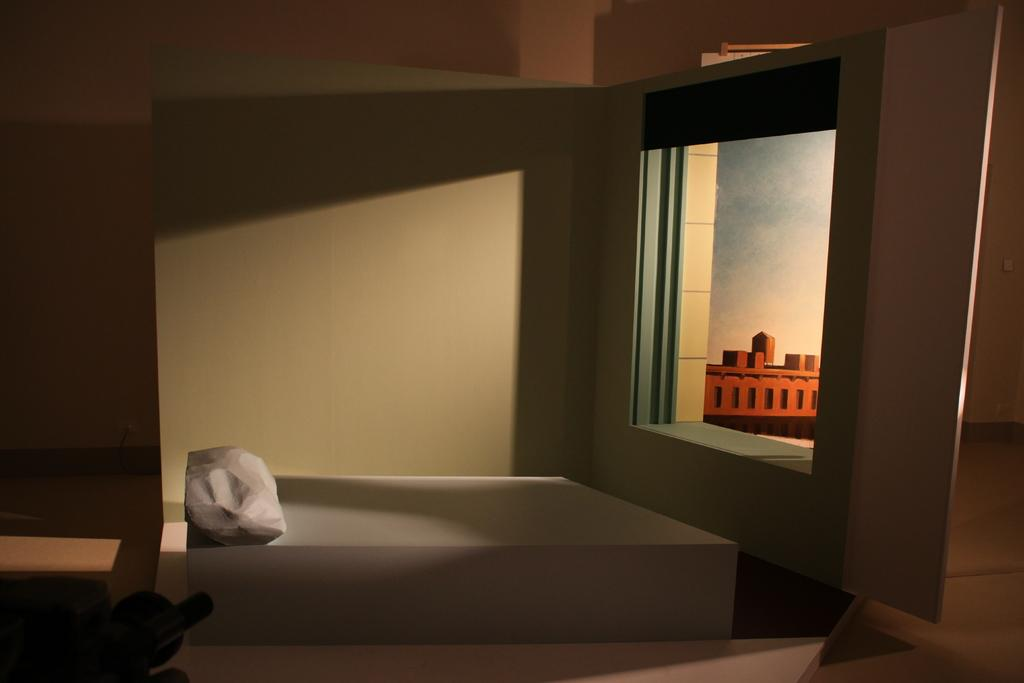Where was the image taken? The image was taken in a room. What is the main object in the center of the image? There is a bench in the center of the image. What can be seen on the right side of the image? There is a wall on the right side of the image. What is hanging on the wall? There is a painting on the wall. What is visible at the bottom of the image? There is a floor visible at the bottom of the image. What type of sponge is being used for writing on the painting in the image? There is no sponge or writing present on the painting in the image. What kind of plastic material can be seen covering the bench in the image? There is no plastic material covering the bench in the image. 